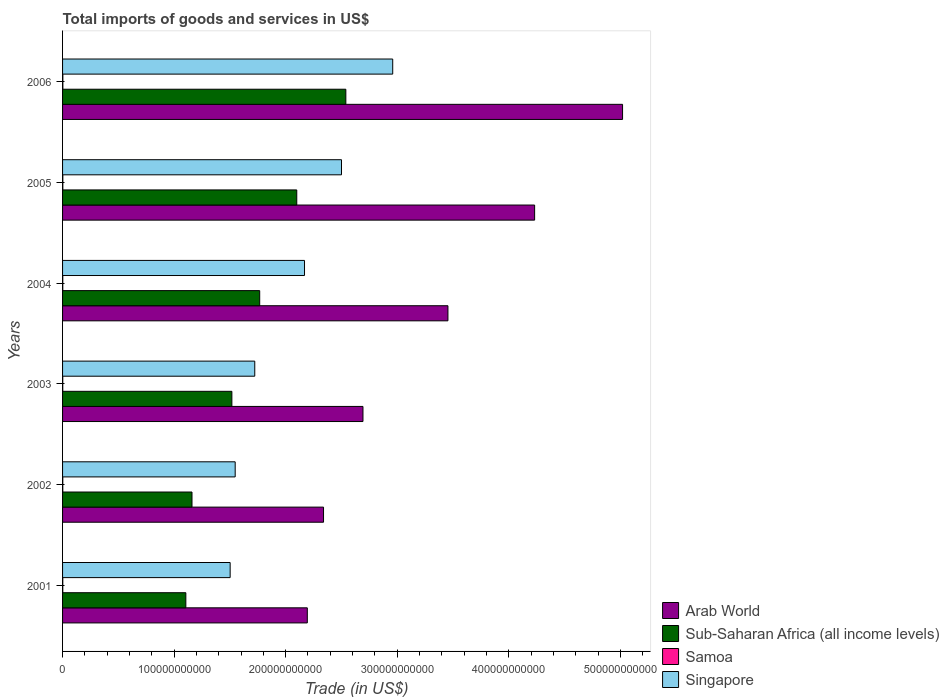Are the number of bars per tick equal to the number of legend labels?
Your response must be concise. Yes. How many bars are there on the 2nd tick from the top?
Your response must be concise. 4. What is the total imports of goods and services in Singapore in 2002?
Ensure brevity in your answer.  1.55e+11. Across all years, what is the maximum total imports of goods and services in Singapore?
Keep it short and to the point. 2.96e+11. Across all years, what is the minimum total imports of goods and services in Singapore?
Ensure brevity in your answer.  1.50e+11. In which year was the total imports of goods and services in Sub-Saharan Africa (all income levels) maximum?
Provide a succinct answer. 2006. In which year was the total imports of goods and services in Samoa minimum?
Your answer should be very brief. 2003. What is the total total imports of goods and services in Singapore in the graph?
Provide a short and direct response. 1.24e+12. What is the difference between the total imports of goods and services in Arab World in 2003 and that in 2005?
Your answer should be very brief. -1.54e+11. What is the difference between the total imports of goods and services in Arab World in 2006 and the total imports of goods and services in Singapore in 2001?
Give a very brief answer. 3.52e+11. What is the average total imports of goods and services in Singapore per year?
Offer a terse response. 2.07e+11. In the year 2002, what is the difference between the total imports of goods and services in Singapore and total imports of goods and services in Arab World?
Offer a very short reply. -7.92e+1. What is the ratio of the total imports of goods and services in Samoa in 2001 to that in 2006?
Your response must be concise. 0.72. Is the difference between the total imports of goods and services in Singapore in 2001 and 2004 greater than the difference between the total imports of goods and services in Arab World in 2001 and 2004?
Your response must be concise. Yes. What is the difference between the highest and the second highest total imports of goods and services in Singapore?
Give a very brief answer. 4.59e+1. What is the difference between the highest and the lowest total imports of goods and services in Arab World?
Offer a terse response. 2.83e+11. In how many years, is the total imports of goods and services in Sub-Saharan Africa (all income levels) greater than the average total imports of goods and services in Sub-Saharan Africa (all income levels) taken over all years?
Keep it short and to the point. 3. Is the sum of the total imports of goods and services in Samoa in 2004 and 2005 greater than the maximum total imports of goods and services in Arab World across all years?
Your answer should be very brief. No. What does the 1st bar from the top in 2006 represents?
Provide a succinct answer. Singapore. What does the 1st bar from the bottom in 2006 represents?
Your answer should be very brief. Arab World. Is it the case that in every year, the sum of the total imports of goods and services in Samoa and total imports of goods and services in Sub-Saharan Africa (all income levels) is greater than the total imports of goods and services in Arab World?
Your answer should be compact. No. How many bars are there?
Your answer should be compact. 24. What is the difference between two consecutive major ticks on the X-axis?
Provide a succinct answer. 1.00e+11. Are the values on the major ticks of X-axis written in scientific E-notation?
Your response must be concise. No. Where does the legend appear in the graph?
Your answer should be very brief. Bottom right. How many legend labels are there?
Offer a terse response. 4. What is the title of the graph?
Offer a very short reply. Total imports of goods and services in US$. Does "High income: nonOECD" appear as one of the legend labels in the graph?
Provide a succinct answer. No. What is the label or title of the X-axis?
Give a very brief answer. Trade (in US$). What is the label or title of the Y-axis?
Keep it short and to the point. Years. What is the Trade (in US$) of Arab World in 2001?
Offer a terse response. 2.19e+11. What is the Trade (in US$) in Sub-Saharan Africa (all income levels) in 2001?
Make the answer very short. 1.11e+11. What is the Trade (in US$) in Samoa in 2001?
Provide a short and direct response. 1.93e+08. What is the Trade (in US$) in Singapore in 2001?
Keep it short and to the point. 1.50e+11. What is the Trade (in US$) in Arab World in 2002?
Ensure brevity in your answer.  2.34e+11. What is the Trade (in US$) of Sub-Saharan Africa (all income levels) in 2002?
Your response must be concise. 1.16e+11. What is the Trade (in US$) of Samoa in 2002?
Offer a terse response. 1.94e+08. What is the Trade (in US$) of Singapore in 2002?
Keep it short and to the point. 1.55e+11. What is the Trade (in US$) of Arab World in 2003?
Offer a very short reply. 2.69e+11. What is the Trade (in US$) in Sub-Saharan Africa (all income levels) in 2003?
Your answer should be compact. 1.52e+11. What is the Trade (in US$) in Samoa in 2003?
Your answer should be compact. 1.63e+08. What is the Trade (in US$) of Singapore in 2003?
Provide a short and direct response. 1.72e+11. What is the Trade (in US$) in Arab World in 2004?
Offer a terse response. 3.45e+11. What is the Trade (in US$) in Sub-Saharan Africa (all income levels) in 2004?
Your answer should be very brief. 1.77e+11. What is the Trade (in US$) in Samoa in 2004?
Offer a terse response. 1.88e+08. What is the Trade (in US$) in Singapore in 2004?
Your response must be concise. 2.17e+11. What is the Trade (in US$) of Arab World in 2005?
Ensure brevity in your answer.  4.23e+11. What is the Trade (in US$) in Sub-Saharan Africa (all income levels) in 2005?
Your answer should be compact. 2.10e+11. What is the Trade (in US$) in Samoa in 2005?
Your answer should be very brief. 2.30e+08. What is the Trade (in US$) in Singapore in 2005?
Offer a terse response. 2.50e+11. What is the Trade (in US$) of Arab World in 2006?
Give a very brief answer. 5.02e+11. What is the Trade (in US$) in Sub-Saharan Africa (all income levels) in 2006?
Ensure brevity in your answer.  2.54e+11. What is the Trade (in US$) in Samoa in 2006?
Provide a short and direct response. 2.66e+08. What is the Trade (in US$) in Singapore in 2006?
Give a very brief answer. 2.96e+11. Across all years, what is the maximum Trade (in US$) in Arab World?
Make the answer very short. 5.02e+11. Across all years, what is the maximum Trade (in US$) in Sub-Saharan Africa (all income levels)?
Your answer should be very brief. 2.54e+11. Across all years, what is the maximum Trade (in US$) of Samoa?
Give a very brief answer. 2.66e+08. Across all years, what is the maximum Trade (in US$) of Singapore?
Your answer should be very brief. 2.96e+11. Across all years, what is the minimum Trade (in US$) in Arab World?
Keep it short and to the point. 2.19e+11. Across all years, what is the minimum Trade (in US$) of Sub-Saharan Africa (all income levels)?
Keep it short and to the point. 1.11e+11. Across all years, what is the minimum Trade (in US$) of Samoa?
Provide a short and direct response. 1.63e+08. Across all years, what is the minimum Trade (in US$) in Singapore?
Provide a short and direct response. 1.50e+11. What is the total Trade (in US$) of Arab World in the graph?
Your answer should be very brief. 1.99e+12. What is the total Trade (in US$) in Sub-Saharan Africa (all income levels) in the graph?
Offer a terse response. 1.02e+12. What is the total Trade (in US$) in Samoa in the graph?
Make the answer very short. 1.23e+09. What is the total Trade (in US$) in Singapore in the graph?
Give a very brief answer. 1.24e+12. What is the difference between the Trade (in US$) of Arab World in 2001 and that in 2002?
Keep it short and to the point. -1.45e+1. What is the difference between the Trade (in US$) of Sub-Saharan Africa (all income levels) in 2001 and that in 2002?
Provide a succinct answer. -5.52e+09. What is the difference between the Trade (in US$) in Samoa in 2001 and that in 2002?
Provide a short and direct response. -1.30e+06. What is the difference between the Trade (in US$) in Singapore in 2001 and that in 2002?
Provide a short and direct response. -4.51e+09. What is the difference between the Trade (in US$) in Arab World in 2001 and that in 2003?
Your answer should be compact. -4.99e+1. What is the difference between the Trade (in US$) of Sub-Saharan Africa (all income levels) in 2001 and that in 2003?
Your answer should be compact. -4.13e+1. What is the difference between the Trade (in US$) in Samoa in 2001 and that in 2003?
Ensure brevity in your answer.  2.97e+07. What is the difference between the Trade (in US$) in Singapore in 2001 and that in 2003?
Provide a short and direct response. -2.21e+1. What is the difference between the Trade (in US$) in Arab World in 2001 and that in 2004?
Ensure brevity in your answer.  -1.26e+11. What is the difference between the Trade (in US$) in Sub-Saharan Africa (all income levels) in 2001 and that in 2004?
Your answer should be compact. -6.62e+1. What is the difference between the Trade (in US$) of Samoa in 2001 and that in 2004?
Ensure brevity in your answer.  4.77e+06. What is the difference between the Trade (in US$) of Singapore in 2001 and that in 2004?
Ensure brevity in your answer.  -6.67e+1. What is the difference between the Trade (in US$) in Arab World in 2001 and that in 2005?
Your answer should be compact. -2.04e+11. What is the difference between the Trade (in US$) of Sub-Saharan Africa (all income levels) in 2001 and that in 2005?
Offer a very short reply. -9.94e+1. What is the difference between the Trade (in US$) of Samoa in 2001 and that in 2005?
Give a very brief answer. -3.73e+07. What is the difference between the Trade (in US$) of Singapore in 2001 and that in 2005?
Provide a succinct answer. -9.98e+1. What is the difference between the Trade (in US$) of Arab World in 2001 and that in 2006?
Your response must be concise. -2.83e+11. What is the difference between the Trade (in US$) in Sub-Saharan Africa (all income levels) in 2001 and that in 2006?
Ensure brevity in your answer.  -1.43e+11. What is the difference between the Trade (in US$) of Samoa in 2001 and that in 2006?
Provide a short and direct response. -7.32e+07. What is the difference between the Trade (in US$) in Singapore in 2001 and that in 2006?
Keep it short and to the point. -1.46e+11. What is the difference between the Trade (in US$) in Arab World in 2002 and that in 2003?
Offer a terse response. -3.54e+1. What is the difference between the Trade (in US$) of Sub-Saharan Africa (all income levels) in 2002 and that in 2003?
Your answer should be very brief. -3.57e+1. What is the difference between the Trade (in US$) in Samoa in 2002 and that in 2003?
Offer a very short reply. 3.10e+07. What is the difference between the Trade (in US$) of Singapore in 2002 and that in 2003?
Make the answer very short. -1.76e+1. What is the difference between the Trade (in US$) in Arab World in 2002 and that in 2004?
Your answer should be very brief. -1.12e+11. What is the difference between the Trade (in US$) of Sub-Saharan Africa (all income levels) in 2002 and that in 2004?
Your answer should be very brief. -6.07e+1. What is the difference between the Trade (in US$) of Samoa in 2002 and that in 2004?
Offer a terse response. 6.06e+06. What is the difference between the Trade (in US$) in Singapore in 2002 and that in 2004?
Your response must be concise. -6.22e+1. What is the difference between the Trade (in US$) of Arab World in 2002 and that in 2005?
Keep it short and to the point. -1.89e+11. What is the difference between the Trade (in US$) in Sub-Saharan Africa (all income levels) in 2002 and that in 2005?
Ensure brevity in your answer.  -9.39e+1. What is the difference between the Trade (in US$) in Samoa in 2002 and that in 2005?
Your answer should be compact. -3.60e+07. What is the difference between the Trade (in US$) of Singapore in 2002 and that in 2005?
Your response must be concise. -9.53e+1. What is the difference between the Trade (in US$) of Arab World in 2002 and that in 2006?
Give a very brief answer. -2.68e+11. What is the difference between the Trade (in US$) of Sub-Saharan Africa (all income levels) in 2002 and that in 2006?
Offer a terse response. -1.38e+11. What is the difference between the Trade (in US$) of Samoa in 2002 and that in 2006?
Offer a very short reply. -7.19e+07. What is the difference between the Trade (in US$) of Singapore in 2002 and that in 2006?
Ensure brevity in your answer.  -1.41e+11. What is the difference between the Trade (in US$) of Arab World in 2003 and that in 2004?
Provide a short and direct response. -7.62e+1. What is the difference between the Trade (in US$) in Sub-Saharan Africa (all income levels) in 2003 and that in 2004?
Provide a short and direct response. -2.50e+1. What is the difference between the Trade (in US$) in Samoa in 2003 and that in 2004?
Offer a very short reply. -2.49e+07. What is the difference between the Trade (in US$) in Singapore in 2003 and that in 2004?
Provide a short and direct response. -4.46e+1. What is the difference between the Trade (in US$) of Arab World in 2003 and that in 2005?
Keep it short and to the point. -1.54e+11. What is the difference between the Trade (in US$) in Sub-Saharan Africa (all income levels) in 2003 and that in 2005?
Your answer should be very brief. -5.82e+1. What is the difference between the Trade (in US$) in Samoa in 2003 and that in 2005?
Offer a very short reply. -6.69e+07. What is the difference between the Trade (in US$) of Singapore in 2003 and that in 2005?
Your answer should be compact. -7.78e+1. What is the difference between the Trade (in US$) in Arab World in 2003 and that in 2006?
Offer a very short reply. -2.33e+11. What is the difference between the Trade (in US$) in Sub-Saharan Africa (all income levels) in 2003 and that in 2006?
Offer a terse response. -1.02e+11. What is the difference between the Trade (in US$) in Samoa in 2003 and that in 2006?
Keep it short and to the point. -1.03e+08. What is the difference between the Trade (in US$) of Singapore in 2003 and that in 2006?
Your answer should be very brief. -1.24e+11. What is the difference between the Trade (in US$) of Arab World in 2004 and that in 2005?
Your response must be concise. -7.77e+1. What is the difference between the Trade (in US$) of Sub-Saharan Africa (all income levels) in 2004 and that in 2005?
Your answer should be compact. -3.32e+1. What is the difference between the Trade (in US$) of Samoa in 2004 and that in 2005?
Give a very brief answer. -4.20e+07. What is the difference between the Trade (in US$) in Singapore in 2004 and that in 2005?
Your response must be concise. -3.32e+1. What is the difference between the Trade (in US$) of Arab World in 2004 and that in 2006?
Your answer should be very brief. -1.57e+11. What is the difference between the Trade (in US$) in Sub-Saharan Africa (all income levels) in 2004 and that in 2006?
Provide a succinct answer. -7.72e+1. What is the difference between the Trade (in US$) of Samoa in 2004 and that in 2006?
Give a very brief answer. -7.80e+07. What is the difference between the Trade (in US$) in Singapore in 2004 and that in 2006?
Your answer should be compact. -7.91e+1. What is the difference between the Trade (in US$) in Arab World in 2005 and that in 2006?
Offer a terse response. -7.88e+1. What is the difference between the Trade (in US$) of Sub-Saharan Africa (all income levels) in 2005 and that in 2006?
Offer a terse response. -4.40e+1. What is the difference between the Trade (in US$) of Samoa in 2005 and that in 2006?
Keep it short and to the point. -3.60e+07. What is the difference between the Trade (in US$) of Singapore in 2005 and that in 2006?
Offer a terse response. -4.59e+1. What is the difference between the Trade (in US$) in Arab World in 2001 and the Trade (in US$) in Sub-Saharan Africa (all income levels) in 2002?
Make the answer very short. 1.03e+11. What is the difference between the Trade (in US$) of Arab World in 2001 and the Trade (in US$) of Samoa in 2002?
Make the answer very short. 2.19e+11. What is the difference between the Trade (in US$) in Arab World in 2001 and the Trade (in US$) in Singapore in 2002?
Give a very brief answer. 6.47e+1. What is the difference between the Trade (in US$) of Sub-Saharan Africa (all income levels) in 2001 and the Trade (in US$) of Samoa in 2002?
Give a very brief answer. 1.10e+11. What is the difference between the Trade (in US$) in Sub-Saharan Africa (all income levels) in 2001 and the Trade (in US$) in Singapore in 2002?
Keep it short and to the point. -4.42e+1. What is the difference between the Trade (in US$) in Samoa in 2001 and the Trade (in US$) in Singapore in 2002?
Your answer should be compact. -1.55e+11. What is the difference between the Trade (in US$) in Arab World in 2001 and the Trade (in US$) in Sub-Saharan Africa (all income levels) in 2003?
Your answer should be compact. 6.76e+1. What is the difference between the Trade (in US$) in Arab World in 2001 and the Trade (in US$) in Samoa in 2003?
Ensure brevity in your answer.  2.19e+11. What is the difference between the Trade (in US$) in Arab World in 2001 and the Trade (in US$) in Singapore in 2003?
Your response must be concise. 4.71e+1. What is the difference between the Trade (in US$) in Sub-Saharan Africa (all income levels) in 2001 and the Trade (in US$) in Samoa in 2003?
Give a very brief answer. 1.10e+11. What is the difference between the Trade (in US$) of Sub-Saharan Africa (all income levels) in 2001 and the Trade (in US$) of Singapore in 2003?
Offer a terse response. -6.18e+1. What is the difference between the Trade (in US$) of Samoa in 2001 and the Trade (in US$) of Singapore in 2003?
Your answer should be very brief. -1.72e+11. What is the difference between the Trade (in US$) in Arab World in 2001 and the Trade (in US$) in Sub-Saharan Africa (all income levels) in 2004?
Ensure brevity in your answer.  4.27e+1. What is the difference between the Trade (in US$) in Arab World in 2001 and the Trade (in US$) in Samoa in 2004?
Provide a succinct answer. 2.19e+11. What is the difference between the Trade (in US$) of Arab World in 2001 and the Trade (in US$) of Singapore in 2004?
Provide a short and direct response. 2.50e+09. What is the difference between the Trade (in US$) in Sub-Saharan Africa (all income levels) in 2001 and the Trade (in US$) in Samoa in 2004?
Make the answer very short. 1.10e+11. What is the difference between the Trade (in US$) of Sub-Saharan Africa (all income levels) in 2001 and the Trade (in US$) of Singapore in 2004?
Your answer should be compact. -1.06e+11. What is the difference between the Trade (in US$) of Samoa in 2001 and the Trade (in US$) of Singapore in 2004?
Your answer should be very brief. -2.17e+11. What is the difference between the Trade (in US$) of Arab World in 2001 and the Trade (in US$) of Sub-Saharan Africa (all income levels) in 2005?
Offer a very short reply. 9.45e+09. What is the difference between the Trade (in US$) in Arab World in 2001 and the Trade (in US$) in Samoa in 2005?
Provide a succinct answer. 2.19e+11. What is the difference between the Trade (in US$) in Arab World in 2001 and the Trade (in US$) in Singapore in 2005?
Your answer should be compact. -3.06e+1. What is the difference between the Trade (in US$) in Sub-Saharan Africa (all income levels) in 2001 and the Trade (in US$) in Samoa in 2005?
Provide a short and direct response. 1.10e+11. What is the difference between the Trade (in US$) of Sub-Saharan Africa (all income levels) in 2001 and the Trade (in US$) of Singapore in 2005?
Ensure brevity in your answer.  -1.40e+11. What is the difference between the Trade (in US$) in Samoa in 2001 and the Trade (in US$) in Singapore in 2005?
Keep it short and to the point. -2.50e+11. What is the difference between the Trade (in US$) of Arab World in 2001 and the Trade (in US$) of Sub-Saharan Africa (all income levels) in 2006?
Your response must be concise. -3.45e+1. What is the difference between the Trade (in US$) in Arab World in 2001 and the Trade (in US$) in Samoa in 2006?
Your response must be concise. 2.19e+11. What is the difference between the Trade (in US$) in Arab World in 2001 and the Trade (in US$) in Singapore in 2006?
Ensure brevity in your answer.  -7.66e+1. What is the difference between the Trade (in US$) in Sub-Saharan Africa (all income levels) in 2001 and the Trade (in US$) in Samoa in 2006?
Provide a short and direct response. 1.10e+11. What is the difference between the Trade (in US$) in Sub-Saharan Africa (all income levels) in 2001 and the Trade (in US$) in Singapore in 2006?
Ensure brevity in your answer.  -1.85e+11. What is the difference between the Trade (in US$) in Samoa in 2001 and the Trade (in US$) in Singapore in 2006?
Offer a terse response. -2.96e+11. What is the difference between the Trade (in US$) of Arab World in 2002 and the Trade (in US$) of Sub-Saharan Africa (all income levels) in 2003?
Provide a short and direct response. 8.22e+1. What is the difference between the Trade (in US$) in Arab World in 2002 and the Trade (in US$) in Samoa in 2003?
Your response must be concise. 2.34e+11. What is the difference between the Trade (in US$) in Arab World in 2002 and the Trade (in US$) in Singapore in 2003?
Offer a very short reply. 6.16e+1. What is the difference between the Trade (in US$) in Sub-Saharan Africa (all income levels) in 2002 and the Trade (in US$) in Samoa in 2003?
Offer a very short reply. 1.16e+11. What is the difference between the Trade (in US$) in Sub-Saharan Africa (all income levels) in 2002 and the Trade (in US$) in Singapore in 2003?
Make the answer very short. -5.63e+1. What is the difference between the Trade (in US$) in Samoa in 2002 and the Trade (in US$) in Singapore in 2003?
Your answer should be very brief. -1.72e+11. What is the difference between the Trade (in US$) of Arab World in 2002 and the Trade (in US$) of Sub-Saharan Africa (all income levels) in 2004?
Your answer should be very brief. 5.72e+1. What is the difference between the Trade (in US$) in Arab World in 2002 and the Trade (in US$) in Samoa in 2004?
Make the answer very short. 2.34e+11. What is the difference between the Trade (in US$) of Arab World in 2002 and the Trade (in US$) of Singapore in 2004?
Ensure brevity in your answer.  1.70e+1. What is the difference between the Trade (in US$) in Sub-Saharan Africa (all income levels) in 2002 and the Trade (in US$) in Samoa in 2004?
Provide a short and direct response. 1.16e+11. What is the difference between the Trade (in US$) of Sub-Saharan Africa (all income levels) in 2002 and the Trade (in US$) of Singapore in 2004?
Keep it short and to the point. -1.01e+11. What is the difference between the Trade (in US$) of Samoa in 2002 and the Trade (in US$) of Singapore in 2004?
Your answer should be very brief. -2.17e+11. What is the difference between the Trade (in US$) of Arab World in 2002 and the Trade (in US$) of Sub-Saharan Africa (all income levels) in 2005?
Make the answer very short. 2.40e+1. What is the difference between the Trade (in US$) of Arab World in 2002 and the Trade (in US$) of Samoa in 2005?
Keep it short and to the point. 2.34e+11. What is the difference between the Trade (in US$) in Arab World in 2002 and the Trade (in US$) in Singapore in 2005?
Give a very brief answer. -1.61e+1. What is the difference between the Trade (in US$) in Sub-Saharan Africa (all income levels) in 2002 and the Trade (in US$) in Samoa in 2005?
Provide a succinct answer. 1.16e+11. What is the difference between the Trade (in US$) of Sub-Saharan Africa (all income levels) in 2002 and the Trade (in US$) of Singapore in 2005?
Give a very brief answer. -1.34e+11. What is the difference between the Trade (in US$) in Samoa in 2002 and the Trade (in US$) in Singapore in 2005?
Your answer should be very brief. -2.50e+11. What is the difference between the Trade (in US$) in Arab World in 2002 and the Trade (in US$) in Sub-Saharan Africa (all income levels) in 2006?
Provide a short and direct response. -2.00e+1. What is the difference between the Trade (in US$) of Arab World in 2002 and the Trade (in US$) of Samoa in 2006?
Ensure brevity in your answer.  2.34e+11. What is the difference between the Trade (in US$) of Arab World in 2002 and the Trade (in US$) of Singapore in 2006?
Offer a very short reply. -6.20e+1. What is the difference between the Trade (in US$) of Sub-Saharan Africa (all income levels) in 2002 and the Trade (in US$) of Samoa in 2006?
Keep it short and to the point. 1.16e+11. What is the difference between the Trade (in US$) in Sub-Saharan Africa (all income levels) in 2002 and the Trade (in US$) in Singapore in 2006?
Your answer should be very brief. -1.80e+11. What is the difference between the Trade (in US$) in Samoa in 2002 and the Trade (in US$) in Singapore in 2006?
Your response must be concise. -2.96e+11. What is the difference between the Trade (in US$) in Arab World in 2003 and the Trade (in US$) in Sub-Saharan Africa (all income levels) in 2004?
Offer a terse response. 9.26e+1. What is the difference between the Trade (in US$) of Arab World in 2003 and the Trade (in US$) of Samoa in 2004?
Provide a succinct answer. 2.69e+11. What is the difference between the Trade (in US$) in Arab World in 2003 and the Trade (in US$) in Singapore in 2004?
Make the answer very short. 5.24e+1. What is the difference between the Trade (in US$) of Sub-Saharan Africa (all income levels) in 2003 and the Trade (in US$) of Samoa in 2004?
Offer a terse response. 1.52e+11. What is the difference between the Trade (in US$) in Sub-Saharan Africa (all income levels) in 2003 and the Trade (in US$) in Singapore in 2004?
Make the answer very short. -6.51e+1. What is the difference between the Trade (in US$) in Samoa in 2003 and the Trade (in US$) in Singapore in 2004?
Offer a very short reply. -2.17e+11. What is the difference between the Trade (in US$) of Arab World in 2003 and the Trade (in US$) of Sub-Saharan Africa (all income levels) in 2005?
Keep it short and to the point. 5.93e+1. What is the difference between the Trade (in US$) of Arab World in 2003 and the Trade (in US$) of Samoa in 2005?
Make the answer very short. 2.69e+11. What is the difference between the Trade (in US$) of Arab World in 2003 and the Trade (in US$) of Singapore in 2005?
Your response must be concise. 1.92e+1. What is the difference between the Trade (in US$) in Sub-Saharan Africa (all income levels) in 2003 and the Trade (in US$) in Samoa in 2005?
Your answer should be very brief. 1.52e+11. What is the difference between the Trade (in US$) of Sub-Saharan Africa (all income levels) in 2003 and the Trade (in US$) of Singapore in 2005?
Provide a succinct answer. -9.83e+1. What is the difference between the Trade (in US$) of Samoa in 2003 and the Trade (in US$) of Singapore in 2005?
Your answer should be very brief. -2.50e+11. What is the difference between the Trade (in US$) of Arab World in 2003 and the Trade (in US$) of Sub-Saharan Africa (all income levels) in 2006?
Offer a terse response. 1.53e+1. What is the difference between the Trade (in US$) in Arab World in 2003 and the Trade (in US$) in Samoa in 2006?
Your response must be concise. 2.69e+11. What is the difference between the Trade (in US$) of Arab World in 2003 and the Trade (in US$) of Singapore in 2006?
Your response must be concise. -2.67e+1. What is the difference between the Trade (in US$) of Sub-Saharan Africa (all income levels) in 2003 and the Trade (in US$) of Samoa in 2006?
Ensure brevity in your answer.  1.52e+11. What is the difference between the Trade (in US$) of Sub-Saharan Africa (all income levels) in 2003 and the Trade (in US$) of Singapore in 2006?
Your response must be concise. -1.44e+11. What is the difference between the Trade (in US$) in Samoa in 2003 and the Trade (in US$) in Singapore in 2006?
Ensure brevity in your answer.  -2.96e+11. What is the difference between the Trade (in US$) of Arab World in 2004 and the Trade (in US$) of Sub-Saharan Africa (all income levels) in 2005?
Offer a terse response. 1.36e+11. What is the difference between the Trade (in US$) in Arab World in 2004 and the Trade (in US$) in Samoa in 2005?
Your answer should be very brief. 3.45e+11. What is the difference between the Trade (in US$) in Arab World in 2004 and the Trade (in US$) in Singapore in 2005?
Your answer should be compact. 9.54e+1. What is the difference between the Trade (in US$) of Sub-Saharan Africa (all income levels) in 2004 and the Trade (in US$) of Samoa in 2005?
Your answer should be compact. 1.76e+11. What is the difference between the Trade (in US$) in Sub-Saharan Africa (all income levels) in 2004 and the Trade (in US$) in Singapore in 2005?
Give a very brief answer. -7.33e+1. What is the difference between the Trade (in US$) in Samoa in 2004 and the Trade (in US$) in Singapore in 2005?
Give a very brief answer. -2.50e+11. What is the difference between the Trade (in US$) of Arab World in 2004 and the Trade (in US$) of Sub-Saharan Africa (all income levels) in 2006?
Offer a very short reply. 9.15e+1. What is the difference between the Trade (in US$) of Arab World in 2004 and the Trade (in US$) of Samoa in 2006?
Offer a terse response. 3.45e+11. What is the difference between the Trade (in US$) of Arab World in 2004 and the Trade (in US$) of Singapore in 2006?
Give a very brief answer. 4.95e+1. What is the difference between the Trade (in US$) in Sub-Saharan Africa (all income levels) in 2004 and the Trade (in US$) in Samoa in 2006?
Offer a very short reply. 1.76e+11. What is the difference between the Trade (in US$) in Sub-Saharan Africa (all income levels) in 2004 and the Trade (in US$) in Singapore in 2006?
Offer a very short reply. -1.19e+11. What is the difference between the Trade (in US$) of Samoa in 2004 and the Trade (in US$) of Singapore in 2006?
Offer a very short reply. -2.96e+11. What is the difference between the Trade (in US$) of Arab World in 2005 and the Trade (in US$) of Sub-Saharan Africa (all income levels) in 2006?
Your response must be concise. 1.69e+11. What is the difference between the Trade (in US$) in Arab World in 2005 and the Trade (in US$) in Samoa in 2006?
Your response must be concise. 4.23e+11. What is the difference between the Trade (in US$) of Arab World in 2005 and the Trade (in US$) of Singapore in 2006?
Your answer should be compact. 1.27e+11. What is the difference between the Trade (in US$) of Sub-Saharan Africa (all income levels) in 2005 and the Trade (in US$) of Samoa in 2006?
Provide a short and direct response. 2.10e+11. What is the difference between the Trade (in US$) in Sub-Saharan Africa (all income levels) in 2005 and the Trade (in US$) in Singapore in 2006?
Keep it short and to the point. -8.60e+1. What is the difference between the Trade (in US$) in Samoa in 2005 and the Trade (in US$) in Singapore in 2006?
Provide a succinct answer. -2.96e+11. What is the average Trade (in US$) of Arab World per year?
Provide a succinct answer. 3.32e+11. What is the average Trade (in US$) of Sub-Saharan Africa (all income levels) per year?
Keep it short and to the point. 1.70e+11. What is the average Trade (in US$) in Samoa per year?
Your answer should be compact. 2.05e+08. What is the average Trade (in US$) in Singapore per year?
Offer a very short reply. 2.07e+11. In the year 2001, what is the difference between the Trade (in US$) in Arab World and Trade (in US$) in Sub-Saharan Africa (all income levels)?
Ensure brevity in your answer.  1.09e+11. In the year 2001, what is the difference between the Trade (in US$) in Arab World and Trade (in US$) in Samoa?
Ensure brevity in your answer.  2.19e+11. In the year 2001, what is the difference between the Trade (in US$) of Arab World and Trade (in US$) of Singapore?
Provide a short and direct response. 6.92e+1. In the year 2001, what is the difference between the Trade (in US$) in Sub-Saharan Africa (all income levels) and Trade (in US$) in Samoa?
Make the answer very short. 1.10e+11. In the year 2001, what is the difference between the Trade (in US$) of Sub-Saharan Africa (all income levels) and Trade (in US$) of Singapore?
Your answer should be compact. -3.97e+1. In the year 2001, what is the difference between the Trade (in US$) in Samoa and Trade (in US$) in Singapore?
Your answer should be compact. -1.50e+11. In the year 2002, what is the difference between the Trade (in US$) in Arab World and Trade (in US$) in Sub-Saharan Africa (all income levels)?
Offer a terse response. 1.18e+11. In the year 2002, what is the difference between the Trade (in US$) in Arab World and Trade (in US$) in Samoa?
Your response must be concise. 2.34e+11. In the year 2002, what is the difference between the Trade (in US$) of Arab World and Trade (in US$) of Singapore?
Keep it short and to the point. 7.92e+1. In the year 2002, what is the difference between the Trade (in US$) in Sub-Saharan Africa (all income levels) and Trade (in US$) in Samoa?
Give a very brief answer. 1.16e+11. In the year 2002, what is the difference between the Trade (in US$) in Sub-Saharan Africa (all income levels) and Trade (in US$) in Singapore?
Your answer should be compact. -3.87e+1. In the year 2002, what is the difference between the Trade (in US$) in Samoa and Trade (in US$) in Singapore?
Make the answer very short. -1.55e+11. In the year 2003, what is the difference between the Trade (in US$) in Arab World and Trade (in US$) in Sub-Saharan Africa (all income levels)?
Offer a very short reply. 1.18e+11. In the year 2003, what is the difference between the Trade (in US$) of Arab World and Trade (in US$) of Samoa?
Your answer should be very brief. 2.69e+11. In the year 2003, what is the difference between the Trade (in US$) in Arab World and Trade (in US$) in Singapore?
Provide a short and direct response. 9.70e+1. In the year 2003, what is the difference between the Trade (in US$) of Sub-Saharan Africa (all income levels) and Trade (in US$) of Samoa?
Make the answer very short. 1.52e+11. In the year 2003, what is the difference between the Trade (in US$) in Sub-Saharan Africa (all income levels) and Trade (in US$) in Singapore?
Make the answer very short. -2.05e+1. In the year 2003, what is the difference between the Trade (in US$) of Samoa and Trade (in US$) of Singapore?
Your answer should be compact. -1.72e+11. In the year 2004, what is the difference between the Trade (in US$) in Arab World and Trade (in US$) in Sub-Saharan Africa (all income levels)?
Your answer should be compact. 1.69e+11. In the year 2004, what is the difference between the Trade (in US$) in Arab World and Trade (in US$) in Samoa?
Your answer should be compact. 3.45e+11. In the year 2004, what is the difference between the Trade (in US$) of Arab World and Trade (in US$) of Singapore?
Your response must be concise. 1.29e+11. In the year 2004, what is the difference between the Trade (in US$) of Sub-Saharan Africa (all income levels) and Trade (in US$) of Samoa?
Your answer should be compact. 1.77e+11. In the year 2004, what is the difference between the Trade (in US$) of Sub-Saharan Africa (all income levels) and Trade (in US$) of Singapore?
Give a very brief answer. -4.02e+1. In the year 2004, what is the difference between the Trade (in US$) in Samoa and Trade (in US$) in Singapore?
Your answer should be very brief. -2.17e+11. In the year 2005, what is the difference between the Trade (in US$) of Arab World and Trade (in US$) of Sub-Saharan Africa (all income levels)?
Your answer should be compact. 2.13e+11. In the year 2005, what is the difference between the Trade (in US$) of Arab World and Trade (in US$) of Samoa?
Ensure brevity in your answer.  4.23e+11. In the year 2005, what is the difference between the Trade (in US$) in Arab World and Trade (in US$) in Singapore?
Give a very brief answer. 1.73e+11. In the year 2005, what is the difference between the Trade (in US$) of Sub-Saharan Africa (all income levels) and Trade (in US$) of Samoa?
Your answer should be very brief. 2.10e+11. In the year 2005, what is the difference between the Trade (in US$) in Sub-Saharan Africa (all income levels) and Trade (in US$) in Singapore?
Give a very brief answer. -4.01e+1. In the year 2005, what is the difference between the Trade (in US$) of Samoa and Trade (in US$) of Singapore?
Give a very brief answer. -2.50e+11. In the year 2006, what is the difference between the Trade (in US$) in Arab World and Trade (in US$) in Sub-Saharan Africa (all income levels)?
Your answer should be compact. 2.48e+11. In the year 2006, what is the difference between the Trade (in US$) of Arab World and Trade (in US$) of Samoa?
Ensure brevity in your answer.  5.02e+11. In the year 2006, what is the difference between the Trade (in US$) of Arab World and Trade (in US$) of Singapore?
Provide a short and direct response. 2.06e+11. In the year 2006, what is the difference between the Trade (in US$) in Sub-Saharan Africa (all income levels) and Trade (in US$) in Samoa?
Make the answer very short. 2.54e+11. In the year 2006, what is the difference between the Trade (in US$) of Sub-Saharan Africa (all income levels) and Trade (in US$) of Singapore?
Ensure brevity in your answer.  -4.20e+1. In the year 2006, what is the difference between the Trade (in US$) of Samoa and Trade (in US$) of Singapore?
Offer a very short reply. -2.96e+11. What is the ratio of the Trade (in US$) in Arab World in 2001 to that in 2002?
Your answer should be very brief. 0.94. What is the ratio of the Trade (in US$) in Sub-Saharan Africa (all income levels) in 2001 to that in 2002?
Make the answer very short. 0.95. What is the ratio of the Trade (in US$) in Samoa in 2001 to that in 2002?
Ensure brevity in your answer.  0.99. What is the ratio of the Trade (in US$) of Singapore in 2001 to that in 2002?
Provide a short and direct response. 0.97. What is the ratio of the Trade (in US$) of Arab World in 2001 to that in 2003?
Provide a short and direct response. 0.81. What is the ratio of the Trade (in US$) of Sub-Saharan Africa (all income levels) in 2001 to that in 2003?
Offer a terse response. 0.73. What is the ratio of the Trade (in US$) of Samoa in 2001 to that in 2003?
Provide a short and direct response. 1.18. What is the ratio of the Trade (in US$) of Singapore in 2001 to that in 2003?
Keep it short and to the point. 0.87. What is the ratio of the Trade (in US$) of Arab World in 2001 to that in 2004?
Provide a short and direct response. 0.64. What is the ratio of the Trade (in US$) of Sub-Saharan Africa (all income levels) in 2001 to that in 2004?
Provide a short and direct response. 0.63. What is the ratio of the Trade (in US$) of Samoa in 2001 to that in 2004?
Keep it short and to the point. 1.03. What is the ratio of the Trade (in US$) in Singapore in 2001 to that in 2004?
Ensure brevity in your answer.  0.69. What is the ratio of the Trade (in US$) of Arab World in 2001 to that in 2005?
Your answer should be compact. 0.52. What is the ratio of the Trade (in US$) in Sub-Saharan Africa (all income levels) in 2001 to that in 2005?
Offer a terse response. 0.53. What is the ratio of the Trade (in US$) of Samoa in 2001 to that in 2005?
Make the answer very short. 0.84. What is the ratio of the Trade (in US$) of Singapore in 2001 to that in 2005?
Keep it short and to the point. 0.6. What is the ratio of the Trade (in US$) in Arab World in 2001 to that in 2006?
Ensure brevity in your answer.  0.44. What is the ratio of the Trade (in US$) in Sub-Saharan Africa (all income levels) in 2001 to that in 2006?
Offer a terse response. 0.44. What is the ratio of the Trade (in US$) in Samoa in 2001 to that in 2006?
Your answer should be compact. 0.72. What is the ratio of the Trade (in US$) in Singapore in 2001 to that in 2006?
Your response must be concise. 0.51. What is the ratio of the Trade (in US$) of Arab World in 2002 to that in 2003?
Offer a terse response. 0.87. What is the ratio of the Trade (in US$) of Sub-Saharan Africa (all income levels) in 2002 to that in 2003?
Make the answer very short. 0.76. What is the ratio of the Trade (in US$) of Samoa in 2002 to that in 2003?
Give a very brief answer. 1.19. What is the ratio of the Trade (in US$) in Singapore in 2002 to that in 2003?
Give a very brief answer. 0.9. What is the ratio of the Trade (in US$) in Arab World in 2002 to that in 2004?
Your response must be concise. 0.68. What is the ratio of the Trade (in US$) in Sub-Saharan Africa (all income levels) in 2002 to that in 2004?
Offer a very short reply. 0.66. What is the ratio of the Trade (in US$) of Samoa in 2002 to that in 2004?
Offer a very short reply. 1.03. What is the ratio of the Trade (in US$) of Singapore in 2002 to that in 2004?
Provide a succinct answer. 0.71. What is the ratio of the Trade (in US$) in Arab World in 2002 to that in 2005?
Provide a short and direct response. 0.55. What is the ratio of the Trade (in US$) of Sub-Saharan Africa (all income levels) in 2002 to that in 2005?
Your answer should be very brief. 0.55. What is the ratio of the Trade (in US$) in Samoa in 2002 to that in 2005?
Give a very brief answer. 0.84. What is the ratio of the Trade (in US$) in Singapore in 2002 to that in 2005?
Provide a succinct answer. 0.62. What is the ratio of the Trade (in US$) in Arab World in 2002 to that in 2006?
Make the answer very short. 0.47. What is the ratio of the Trade (in US$) in Sub-Saharan Africa (all income levels) in 2002 to that in 2006?
Give a very brief answer. 0.46. What is the ratio of the Trade (in US$) in Samoa in 2002 to that in 2006?
Offer a terse response. 0.73. What is the ratio of the Trade (in US$) in Singapore in 2002 to that in 2006?
Your answer should be very brief. 0.52. What is the ratio of the Trade (in US$) in Arab World in 2003 to that in 2004?
Give a very brief answer. 0.78. What is the ratio of the Trade (in US$) of Sub-Saharan Africa (all income levels) in 2003 to that in 2004?
Offer a very short reply. 0.86. What is the ratio of the Trade (in US$) of Samoa in 2003 to that in 2004?
Provide a short and direct response. 0.87. What is the ratio of the Trade (in US$) of Singapore in 2003 to that in 2004?
Your response must be concise. 0.79. What is the ratio of the Trade (in US$) in Arab World in 2003 to that in 2005?
Provide a succinct answer. 0.64. What is the ratio of the Trade (in US$) in Sub-Saharan Africa (all income levels) in 2003 to that in 2005?
Your response must be concise. 0.72. What is the ratio of the Trade (in US$) of Samoa in 2003 to that in 2005?
Make the answer very short. 0.71. What is the ratio of the Trade (in US$) in Singapore in 2003 to that in 2005?
Give a very brief answer. 0.69. What is the ratio of the Trade (in US$) in Arab World in 2003 to that in 2006?
Your response must be concise. 0.54. What is the ratio of the Trade (in US$) of Sub-Saharan Africa (all income levels) in 2003 to that in 2006?
Your response must be concise. 0.6. What is the ratio of the Trade (in US$) in Samoa in 2003 to that in 2006?
Make the answer very short. 0.61. What is the ratio of the Trade (in US$) in Singapore in 2003 to that in 2006?
Provide a succinct answer. 0.58. What is the ratio of the Trade (in US$) in Arab World in 2004 to that in 2005?
Your answer should be compact. 0.82. What is the ratio of the Trade (in US$) in Sub-Saharan Africa (all income levels) in 2004 to that in 2005?
Provide a succinct answer. 0.84. What is the ratio of the Trade (in US$) of Samoa in 2004 to that in 2005?
Offer a terse response. 0.82. What is the ratio of the Trade (in US$) in Singapore in 2004 to that in 2005?
Provide a succinct answer. 0.87. What is the ratio of the Trade (in US$) of Arab World in 2004 to that in 2006?
Offer a very short reply. 0.69. What is the ratio of the Trade (in US$) in Sub-Saharan Africa (all income levels) in 2004 to that in 2006?
Make the answer very short. 0.7. What is the ratio of the Trade (in US$) in Samoa in 2004 to that in 2006?
Give a very brief answer. 0.71. What is the ratio of the Trade (in US$) in Singapore in 2004 to that in 2006?
Give a very brief answer. 0.73. What is the ratio of the Trade (in US$) in Arab World in 2005 to that in 2006?
Make the answer very short. 0.84. What is the ratio of the Trade (in US$) of Sub-Saharan Africa (all income levels) in 2005 to that in 2006?
Ensure brevity in your answer.  0.83. What is the ratio of the Trade (in US$) of Samoa in 2005 to that in 2006?
Make the answer very short. 0.86. What is the ratio of the Trade (in US$) of Singapore in 2005 to that in 2006?
Your response must be concise. 0.84. What is the difference between the highest and the second highest Trade (in US$) of Arab World?
Your answer should be compact. 7.88e+1. What is the difference between the highest and the second highest Trade (in US$) in Sub-Saharan Africa (all income levels)?
Give a very brief answer. 4.40e+1. What is the difference between the highest and the second highest Trade (in US$) in Samoa?
Your response must be concise. 3.60e+07. What is the difference between the highest and the second highest Trade (in US$) of Singapore?
Your answer should be compact. 4.59e+1. What is the difference between the highest and the lowest Trade (in US$) in Arab World?
Offer a terse response. 2.83e+11. What is the difference between the highest and the lowest Trade (in US$) of Sub-Saharan Africa (all income levels)?
Ensure brevity in your answer.  1.43e+11. What is the difference between the highest and the lowest Trade (in US$) of Samoa?
Offer a terse response. 1.03e+08. What is the difference between the highest and the lowest Trade (in US$) of Singapore?
Offer a terse response. 1.46e+11. 